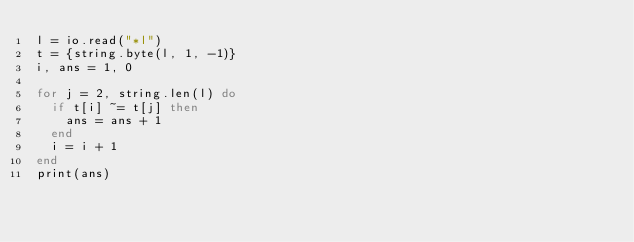<code> <loc_0><loc_0><loc_500><loc_500><_Lua_>l = io.read("*l")
t = {string.byte(l, 1, -1)} 
i, ans = 1, 0
 
for j = 2, string.len(l) do
	if t[i] ~= t[j] then
		ans = ans + 1
	end
	i = i + 1
end
print(ans)
</code> 